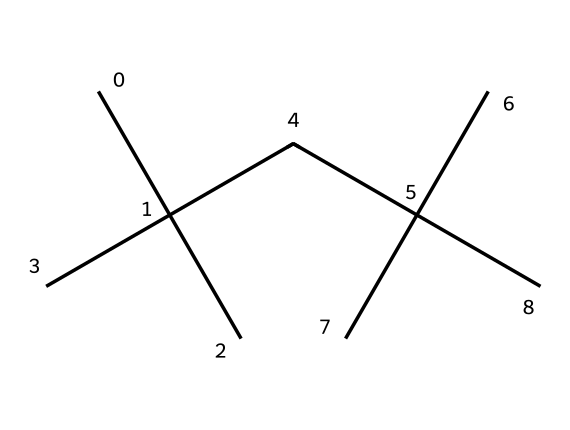What is the main element in the polymer structure? The chemical structure indicates a hydrocarbon composition, predominantly consisting of carbon atoms as inferred from the absence of heteroatoms.
Answer: carbon How many carbon atoms are in this polymer? By analyzing the provided SMILES, there are 15 carbon atoms visually represented by the letter "C".
Answer: 15 What type of polymer is represented by this structure? The structure is indicative of a branched alkane polymer, commonly used in the production of fishing lines due to its properties.
Answer: branched alkane Does this polymer exhibit flexibility? This polymer's branched structure is designed to provide flexibility, which is ideal for fishing lines, allowing them to bend without breaking.
Answer: yes What is the primary use of this polymer in Alabama's waters? This polymer's characteristics, including strength and resistance to corrosion, make it ideal for fishing line applications in Alabama's lakes and rivers.
Answer: fishing line What characteristic of this structure contributes to its strength? The branched nature of the polymer enhances intermolecular forces, providing greater tensile strength, essential for effective fishing lines.
Answer: branched structure Is this polymer hydrophobic or hydrophilic? The purely hydrocarbon chain indicates that this polymer is hydrophobic, repelling water and reducing absorption, which is advantageous for fishing lines.
Answer: hydrophobic 